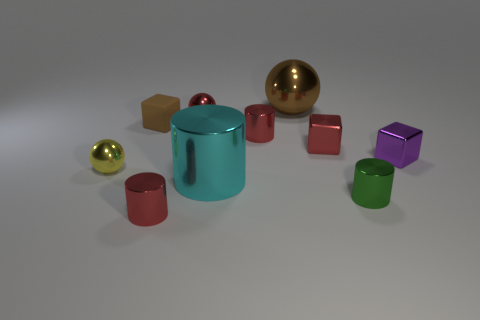Subtract all tiny metallic spheres. How many spheres are left? 1 Subtract 4 cylinders. How many cylinders are left? 0 Subtract all red spheres. How many spheres are left? 2 Subtract 0 green balls. How many objects are left? 10 Subtract all blocks. How many objects are left? 7 Subtract all yellow blocks. Subtract all gray balls. How many blocks are left? 3 Subtract all purple cubes. How many purple balls are left? 0 Subtract all small shiny cubes. Subtract all big cyan shiny things. How many objects are left? 7 Add 3 tiny red cylinders. How many tiny red cylinders are left? 5 Add 7 purple metal objects. How many purple metal objects exist? 8 